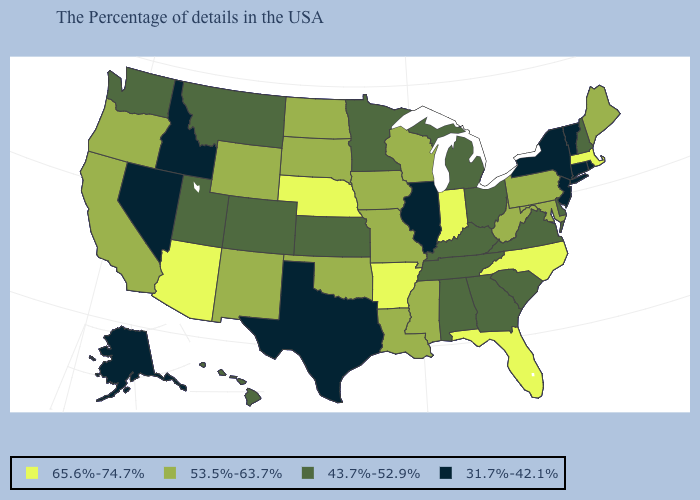What is the highest value in the USA?
Keep it brief. 65.6%-74.7%. Which states have the lowest value in the MidWest?
Be succinct. Illinois. Among the states that border Ohio , which have the highest value?
Quick response, please. Indiana. Which states hav the highest value in the MidWest?
Write a very short answer. Indiana, Nebraska. Name the states that have a value in the range 65.6%-74.7%?
Concise answer only. Massachusetts, North Carolina, Florida, Indiana, Arkansas, Nebraska, Arizona. Which states have the lowest value in the West?
Keep it brief. Idaho, Nevada, Alaska. What is the value of Louisiana?
Concise answer only. 53.5%-63.7%. Does Nevada have the lowest value in the USA?
Answer briefly. Yes. Which states have the lowest value in the MidWest?
Answer briefly. Illinois. What is the lowest value in states that border Ohio?
Short answer required. 43.7%-52.9%. Which states have the lowest value in the USA?
Be succinct. Rhode Island, Vermont, Connecticut, New York, New Jersey, Illinois, Texas, Idaho, Nevada, Alaska. What is the value of Delaware?
Keep it brief. 43.7%-52.9%. Which states have the highest value in the USA?
Short answer required. Massachusetts, North Carolina, Florida, Indiana, Arkansas, Nebraska, Arizona. Does Massachusetts have the highest value in the Northeast?
Concise answer only. Yes. 